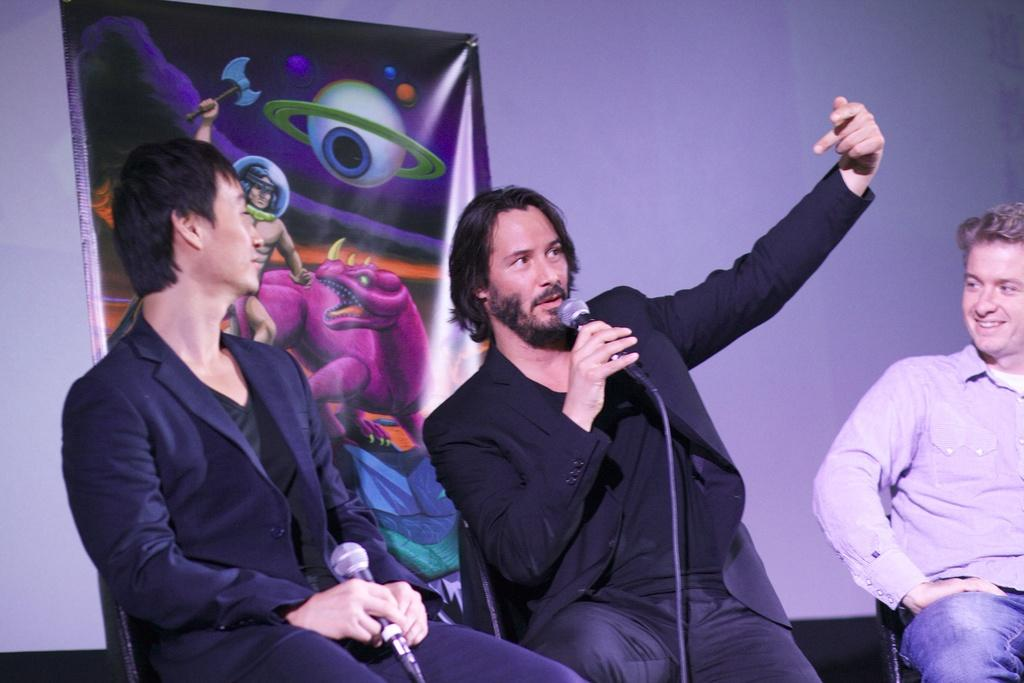How many people are sitting in the image? There are three persons sitting in the image. What are the people doing in the image? One person is holding a microphone and talking, while another person is also holding a microphone. What can be seen in the background of the image? There is a wall and a banner in the background of the image. What type of level is being used by the lawyer in the image? There is no lawyer or level present in the image. What is the aunt doing in the image? There is no aunt present in the image. 